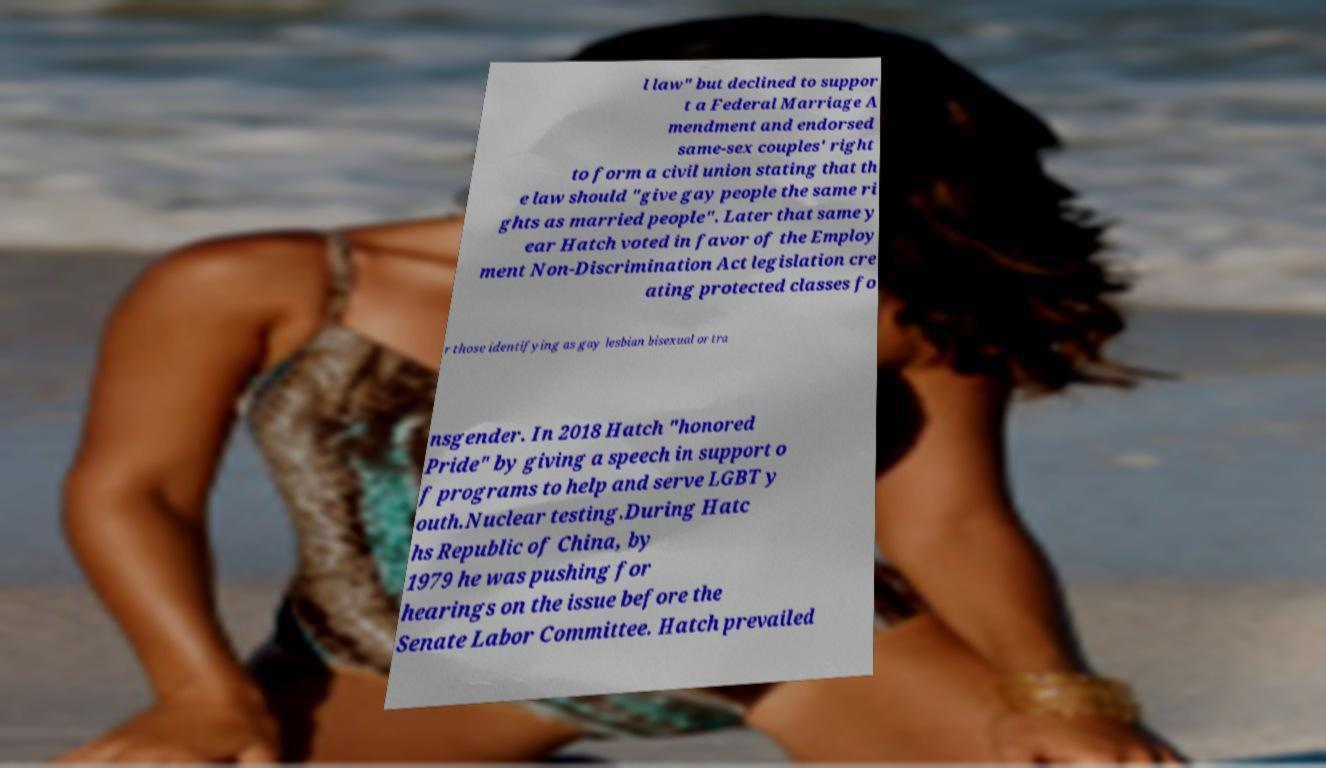Can you read and provide the text displayed in the image?This photo seems to have some interesting text. Can you extract and type it out for me? l law" but declined to suppor t a Federal Marriage A mendment and endorsed same-sex couples' right to form a civil union stating that th e law should "give gay people the same ri ghts as married people". Later that same y ear Hatch voted in favor of the Employ ment Non-Discrimination Act legislation cre ating protected classes fo r those identifying as gay lesbian bisexual or tra nsgender. In 2018 Hatch "honored Pride" by giving a speech in support o f programs to help and serve LGBT y outh.Nuclear testing.During Hatc hs Republic of China, by 1979 he was pushing for hearings on the issue before the Senate Labor Committee. Hatch prevailed 